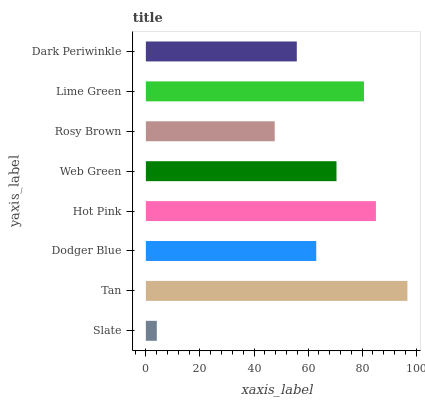Is Slate the minimum?
Answer yes or no. Yes. Is Tan the maximum?
Answer yes or no. Yes. Is Dodger Blue the minimum?
Answer yes or no. No. Is Dodger Blue the maximum?
Answer yes or no. No. Is Tan greater than Dodger Blue?
Answer yes or no. Yes. Is Dodger Blue less than Tan?
Answer yes or no. Yes. Is Dodger Blue greater than Tan?
Answer yes or no. No. Is Tan less than Dodger Blue?
Answer yes or no. No. Is Web Green the high median?
Answer yes or no. Yes. Is Dodger Blue the low median?
Answer yes or no. Yes. Is Tan the high median?
Answer yes or no. No. Is Slate the low median?
Answer yes or no. No. 